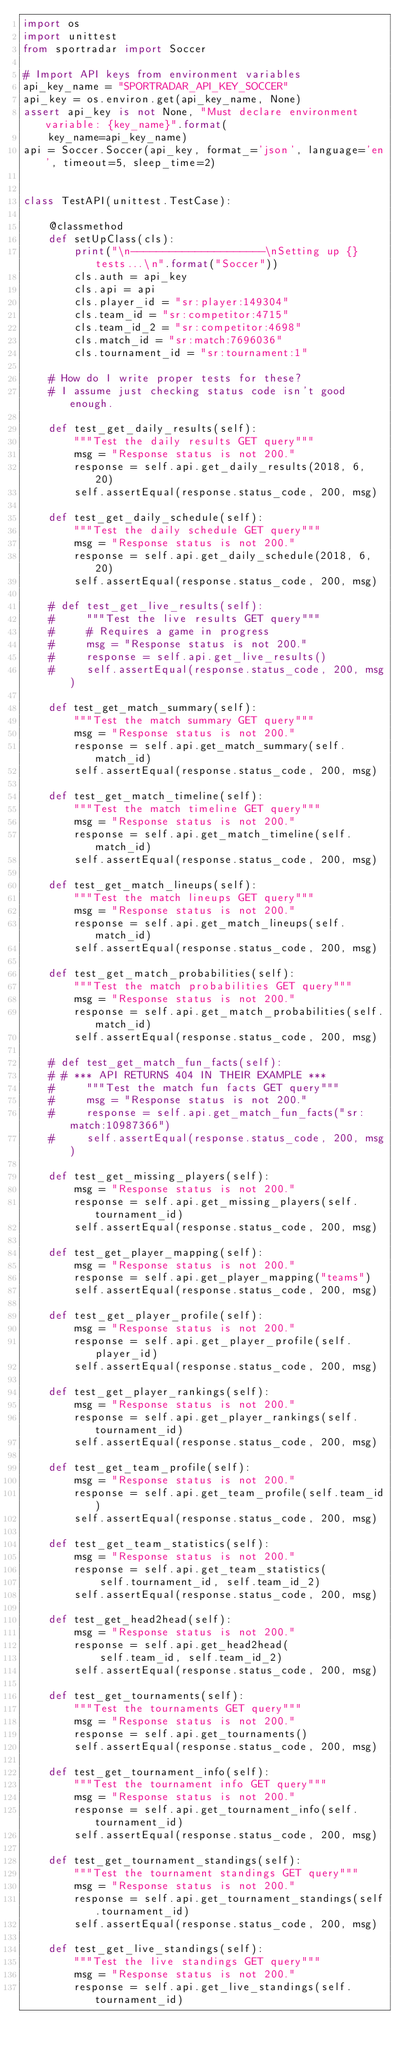Convert code to text. <code><loc_0><loc_0><loc_500><loc_500><_Python_>import os
import unittest
from sportradar import Soccer

# Import API keys from environment variables
api_key_name = "SPORTRADAR_API_KEY_SOCCER"
api_key = os.environ.get(api_key_name, None)
assert api_key is not None, "Must declare environment variable: {key_name}".format(
    key_name=api_key_name)
api = Soccer.Soccer(api_key, format_='json', language='en', timeout=5, sleep_time=2)


class TestAPI(unittest.TestCase):

    @classmethod
    def setUpClass(cls):
        print("\n---------------------\nSetting up {} tests...\n".format("Soccer"))
        cls.auth = api_key
        cls.api = api
        cls.player_id = "sr:player:149304"
        cls.team_id = "sr:competitor:4715"
        cls.team_id_2 = "sr:competitor:4698"
        cls.match_id = "sr:match:7696036"
        cls.tournament_id = "sr:tournament:1"

    # How do I write proper tests for these?
    # I assume just checking status code isn't good enough.

    def test_get_daily_results(self):
        """Test the daily results GET query"""
        msg = "Response status is not 200."
        response = self.api.get_daily_results(2018, 6, 20)
        self.assertEqual(response.status_code, 200, msg)

    def test_get_daily_schedule(self):
        """Test the daily schedule GET query"""
        msg = "Response status is not 200."
        response = self.api.get_daily_schedule(2018, 6, 20)
        self.assertEqual(response.status_code, 200, msg)

    # def test_get_live_results(self):
    #     """Test the live results GET query"""
    #     # Requires a game in progress
    #     msg = "Response status is not 200."
    #     response = self.api.get_live_results()
    #     self.assertEqual(response.status_code, 200, msg)

    def test_get_match_summary(self):
        """Test the match summary GET query"""
        msg = "Response status is not 200."
        response = self.api.get_match_summary(self.match_id)
        self.assertEqual(response.status_code, 200, msg)

    def test_get_match_timeline(self):
        """Test the match timeline GET query"""
        msg = "Response status is not 200."
        response = self.api.get_match_timeline(self.match_id)
        self.assertEqual(response.status_code, 200, msg)

    def test_get_match_lineups(self):
        """Test the match lineups GET query"""
        msg = "Response status is not 200."
        response = self.api.get_match_lineups(self.match_id)
        self.assertEqual(response.status_code, 200, msg)

    def test_get_match_probabilities(self):
        """Test the match probabilities GET query"""
        msg = "Response status is not 200."
        response = self.api.get_match_probabilities(self.match_id)
        self.assertEqual(response.status_code, 200, msg)

    # def test_get_match_fun_facts(self):
    # # *** API RETURNS 404 IN THEIR EXAMPLE ***
    #     """Test the match fun facts GET query"""
    #     msg = "Response status is not 200."
    #     response = self.api.get_match_fun_facts("sr:match:10987366")
    #     self.assertEqual(response.status_code, 200, msg)

    def test_get_missing_players(self):
        msg = "Response status is not 200."
        response = self.api.get_missing_players(self.tournament_id)
        self.assertEqual(response.status_code, 200, msg)

    def test_get_player_mapping(self):
        msg = "Response status is not 200."
        response = self.api.get_player_mapping("teams")
        self.assertEqual(response.status_code, 200, msg)

    def test_get_player_profile(self):
        msg = "Response status is not 200."
        response = self.api.get_player_profile(self.player_id)
        self.assertEqual(response.status_code, 200, msg)

    def test_get_player_rankings(self):
        msg = "Response status is not 200."
        response = self.api.get_player_rankings(self.tournament_id)
        self.assertEqual(response.status_code, 200, msg)

    def test_get_team_profile(self):
        msg = "Response status is not 200."
        response = self.api.get_team_profile(self.team_id)
        self.assertEqual(response.status_code, 200, msg)

    def test_get_team_statistics(self):
        msg = "Response status is not 200."
        response = self.api.get_team_statistics(
            self.tournament_id, self.team_id_2)
        self.assertEqual(response.status_code, 200, msg)

    def test_get_head2head(self):
        msg = "Response status is not 200."
        response = self.api.get_head2head(
            self.team_id, self.team_id_2)
        self.assertEqual(response.status_code, 200, msg)

    def test_get_tournaments(self):
        """Test the tournaments GET query"""
        msg = "Response status is not 200."
        response = self.api.get_tournaments()
        self.assertEqual(response.status_code, 200, msg)

    def test_get_tournament_info(self):
        """Test the tournament info GET query"""
        msg = "Response status is not 200."
        response = self.api.get_tournament_info(self.tournament_id)
        self.assertEqual(response.status_code, 200, msg)

    def test_get_tournament_standings(self):
        """Test the tournament standings GET query"""
        msg = "Response status is not 200."
        response = self.api.get_tournament_standings(self.tournament_id)
        self.assertEqual(response.status_code, 200, msg)

    def test_get_live_standings(self):
        """Test the live standings GET query"""
        msg = "Response status is not 200."
        response = self.api.get_live_standings(self.tournament_id)</code> 